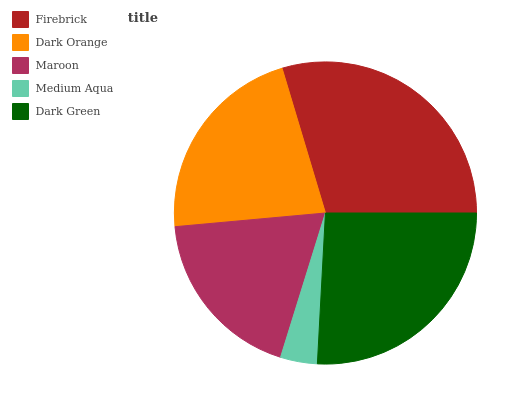Is Medium Aqua the minimum?
Answer yes or no. Yes. Is Firebrick the maximum?
Answer yes or no. Yes. Is Dark Orange the minimum?
Answer yes or no. No. Is Dark Orange the maximum?
Answer yes or no. No. Is Firebrick greater than Dark Orange?
Answer yes or no. Yes. Is Dark Orange less than Firebrick?
Answer yes or no. Yes. Is Dark Orange greater than Firebrick?
Answer yes or no. No. Is Firebrick less than Dark Orange?
Answer yes or no. No. Is Dark Orange the high median?
Answer yes or no. Yes. Is Dark Orange the low median?
Answer yes or no. Yes. Is Maroon the high median?
Answer yes or no. No. Is Firebrick the low median?
Answer yes or no. No. 